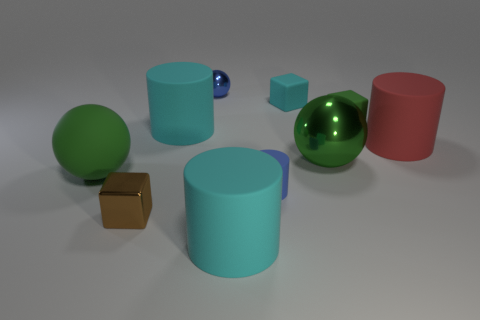Is the number of small blue cylinders that are behind the large green rubber sphere less than the number of tiny blue things that are right of the brown metallic thing?
Offer a very short reply. Yes. There is a big object that is in front of the large green metallic thing and right of the metal block; what is its shape?
Offer a terse response. Cylinder. How many other small rubber objects have the same shape as the tiny green thing?
Ensure brevity in your answer.  1. There is a sphere that is the same material as the large red thing; what size is it?
Make the answer very short. Large. Is the number of small cyan matte objects greater than the number of metal objects?
Your answer should be compact. No. There is a rubber cylinder that is behind the large red thing; what is its color?
Your answer should be compact. Cyan. What size is the thing that is behind the large metal sphere and on the left side of the tiny ball?
Offer a very short reply. Large. How many cyan blocks are the same size as the blue shiny sphere?
Your answer should be very brief. 1. There is a tiny green thing that is the same shape as the small cyan thing; what is its material?
Offer a very short reply. Rubber. Do the red rubber thing and the tiny blue matte thing have the same shape?
Provide a short and direct response. Yes. 